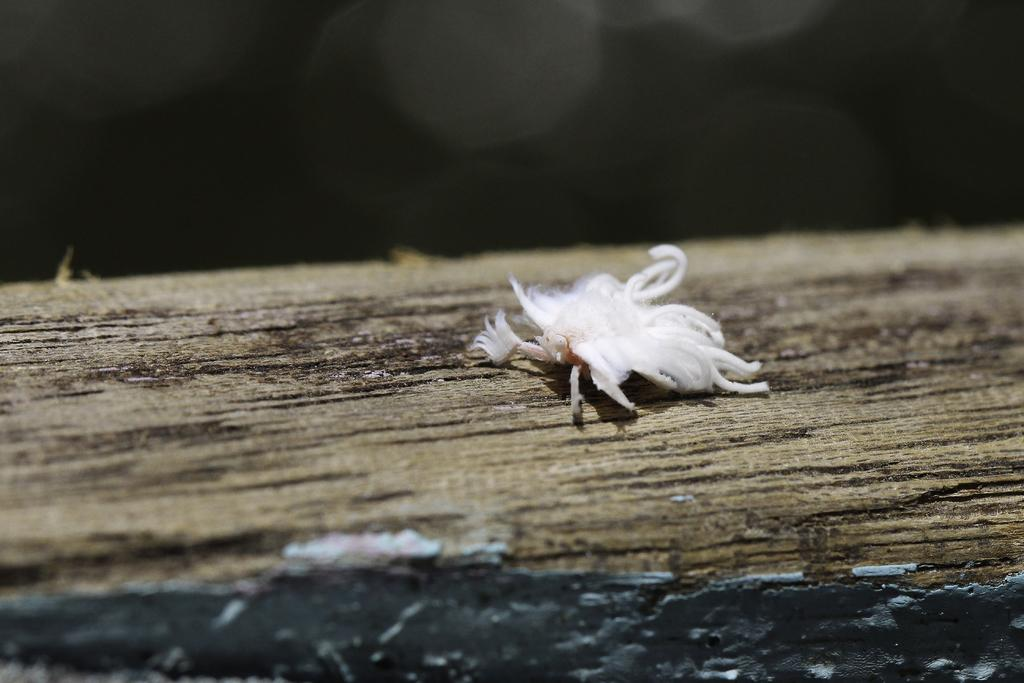What is the color of the object that is visible in the image? The object in the image is white. Where is the white object located in the image? The white object is placed on a surface. What can be seen in the blurry area at the top of the image? Unfortunately, the view at the top of the image is too blurry to make out any specific details. How does the stomach of the person in the image feel after eating a heavy meal? There is no person present in the image, and therefore no information about their stomach or eating habits can be determined. 